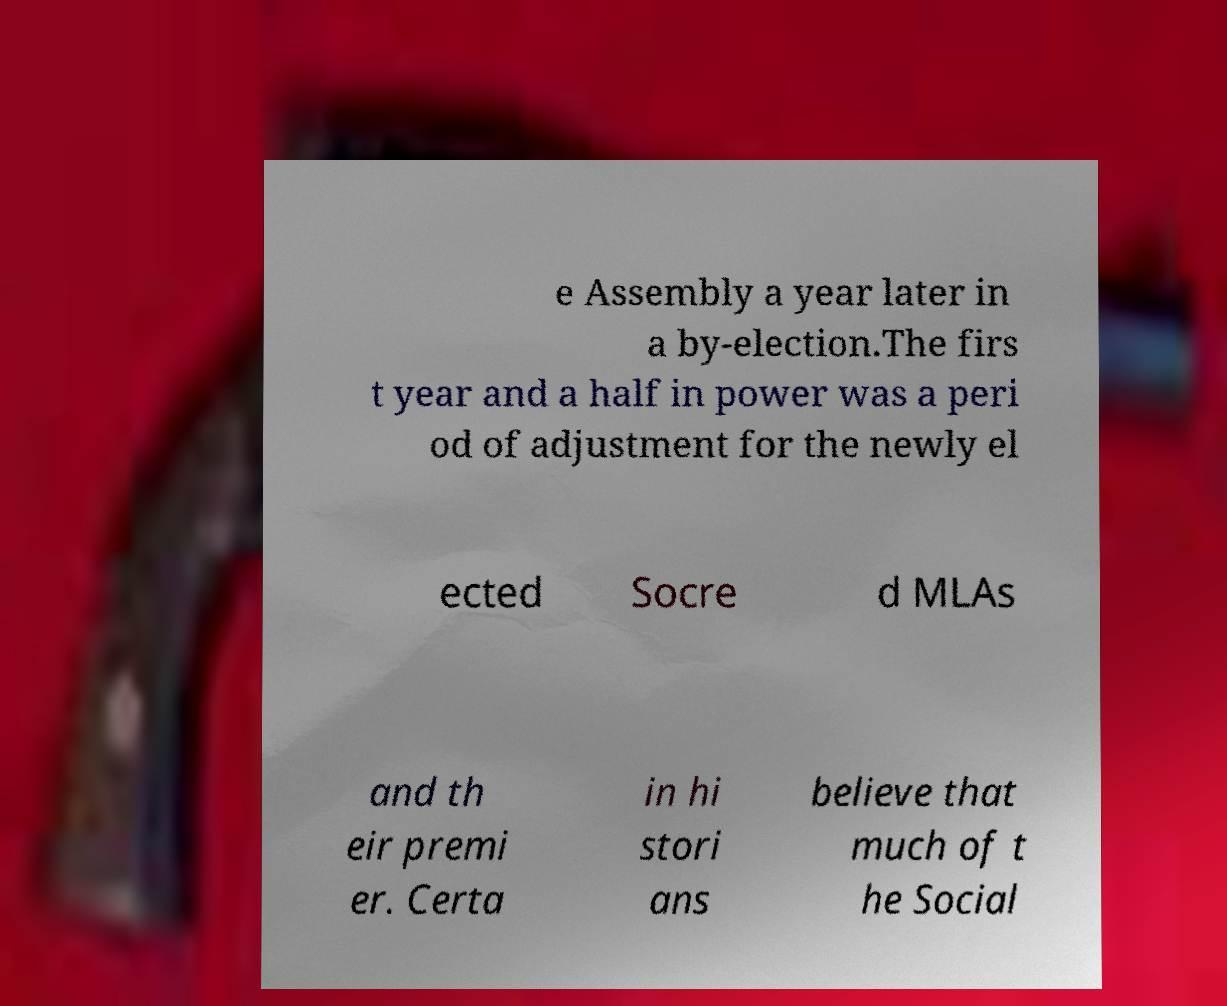There's text embedded in this image that I need extracted. Can you transcribe it verbatim? e Assembly a year later in a by-election.The firs t year and a half in power was a peri od of adjustment for the newly el ected Socre d MLAs and th eir premi er. Certa in hi stori ans believe that much of t he Social 